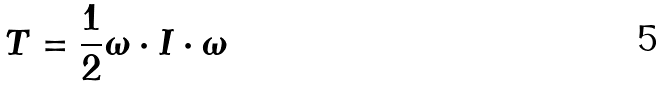<formula> <loc_0><loc_0><loc_500><loc_500>T = \frac { 1 } { 2 } \omega \cdot I \cdot \omega</formula> 